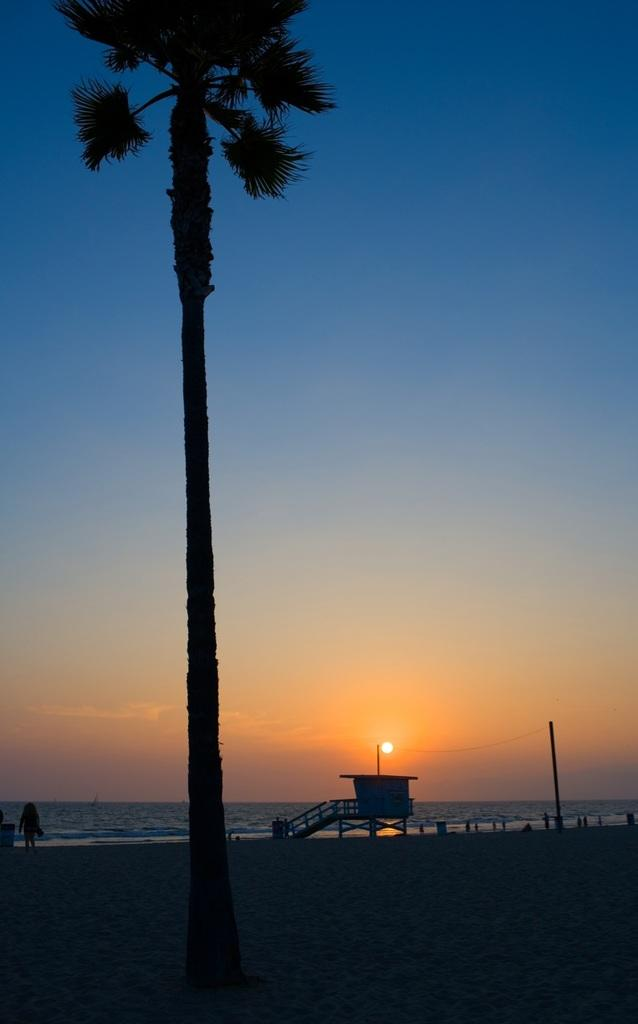What is the lighting condition in the image? The image is taken in the dark. What type of vegetation can be seen in the image? There is a tree in the image. What type of terrain is visible in the image? There is sand in the image. Can you describe the person in the image? There is a person in the image. What architectural feature is present in the image? There are stairs in the image. What is the purpose of the pole in the image? There is a pole in the image. What is the purpose of the wires in the image? There are wires in the image. What type of body of water is visible in the image? There is water in the image. What celestial body is visible in the image? The sun is visible in the image. What is the color of the sky in the background of the image? The sky in the background is pale blue. What type of error can be seen in the image? There is no error present in the image. What type of pot is visible in the image? There is no pot present in the image. What type of flight is depicted in the image? There is no flight depicted in the image. 